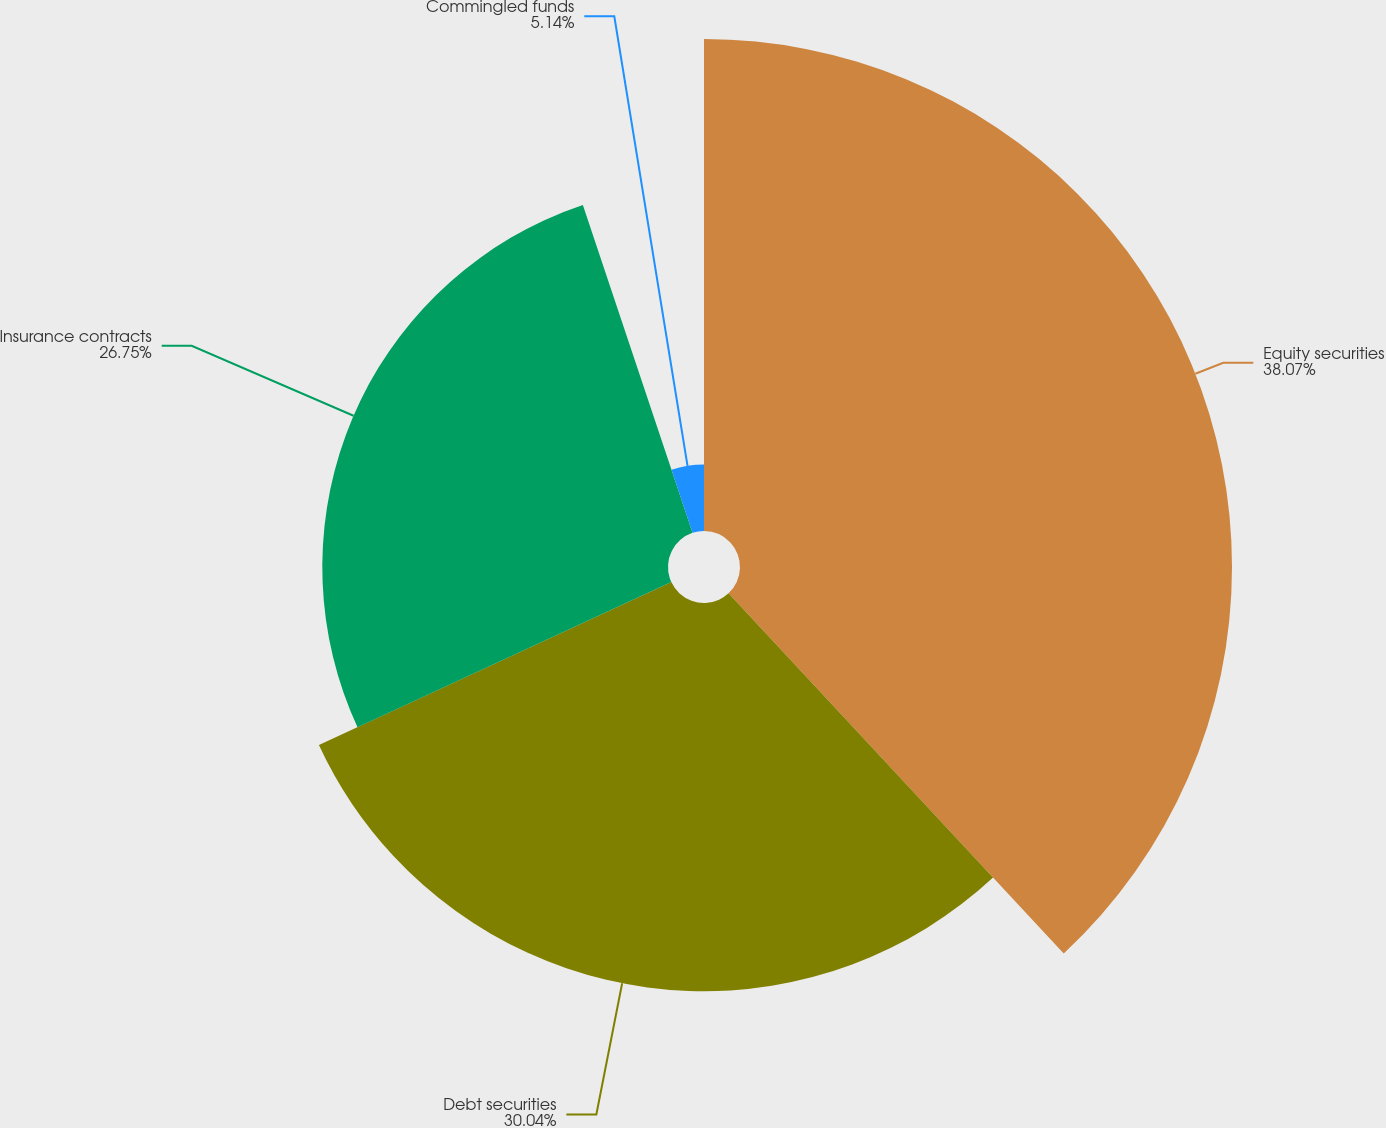<chart> <loc_0><loc_0><loc_500><loc_500><pie_chart><fcel>Equity securities<fcel>Debt securities<fcel>Insurance contracts<fcel>Commingled funds<nl><fcel>38.07%<fcel>30.04%<fcel>26.75%<fcel>5.14%<nl></chart> 